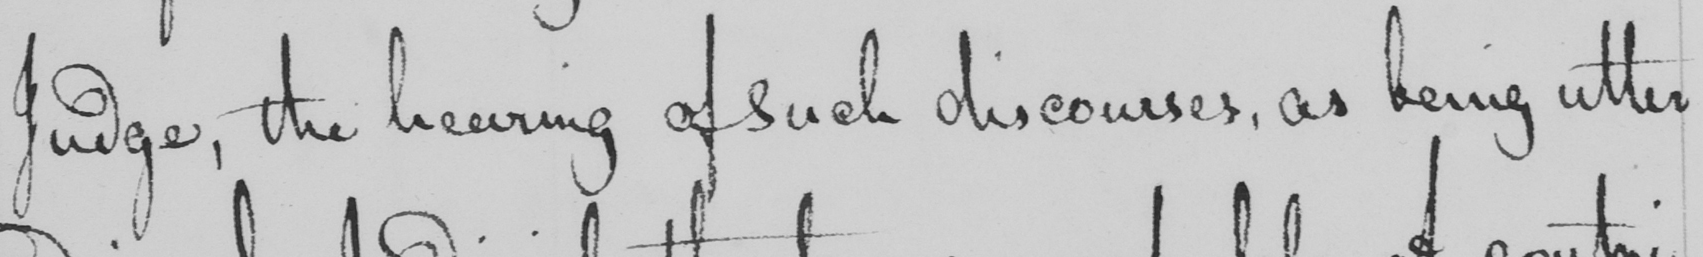What text is written in this handwritten line? Judge , the hearing of such discourses , as being utter 